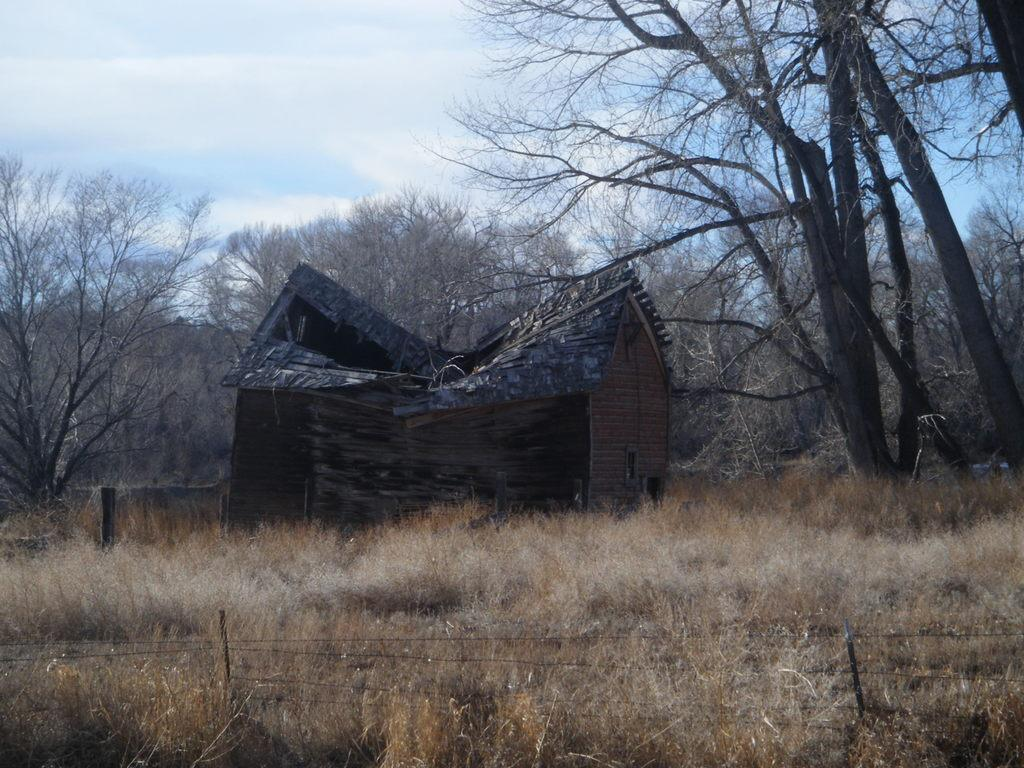What type of temporary shelters can be seen in the image? There are tents in the image. What natural elements are present in the image? There are trees, plants, and dry grass in the image. What type of barrier can be seen in the image? There are fences in the image. What part of the natural environment is visible in the background of the image? The sky is visible in the background of the image. What time of day is it in the image, as indicated by the hour on a clock? There is no clock present in the image, so it is not possible to determine the time of day. What type of animal is taking a bite out of the tent in the image? There are no animals present in the image, and the tents are not being bitten or damaged. 